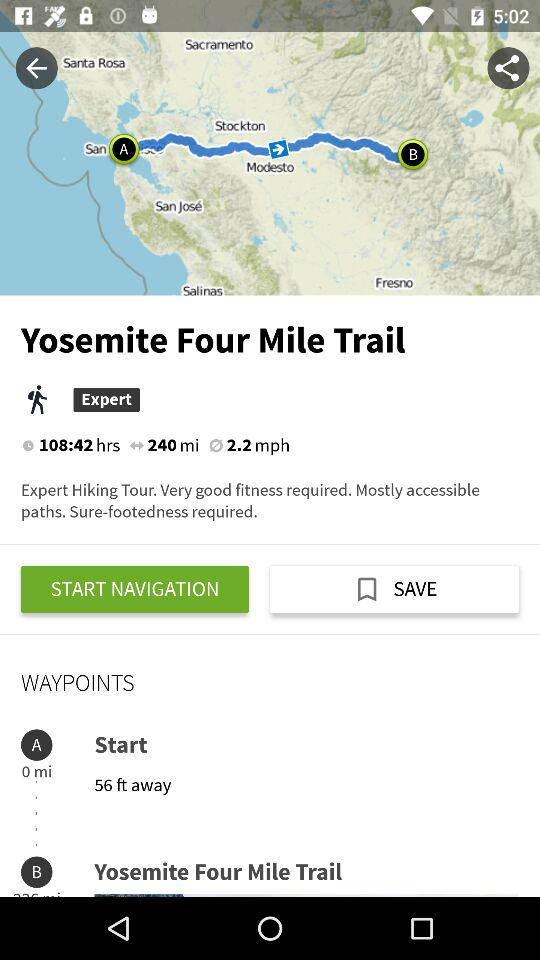How long does trekking take in total? The trekking takes a total of 108:42 hours. 